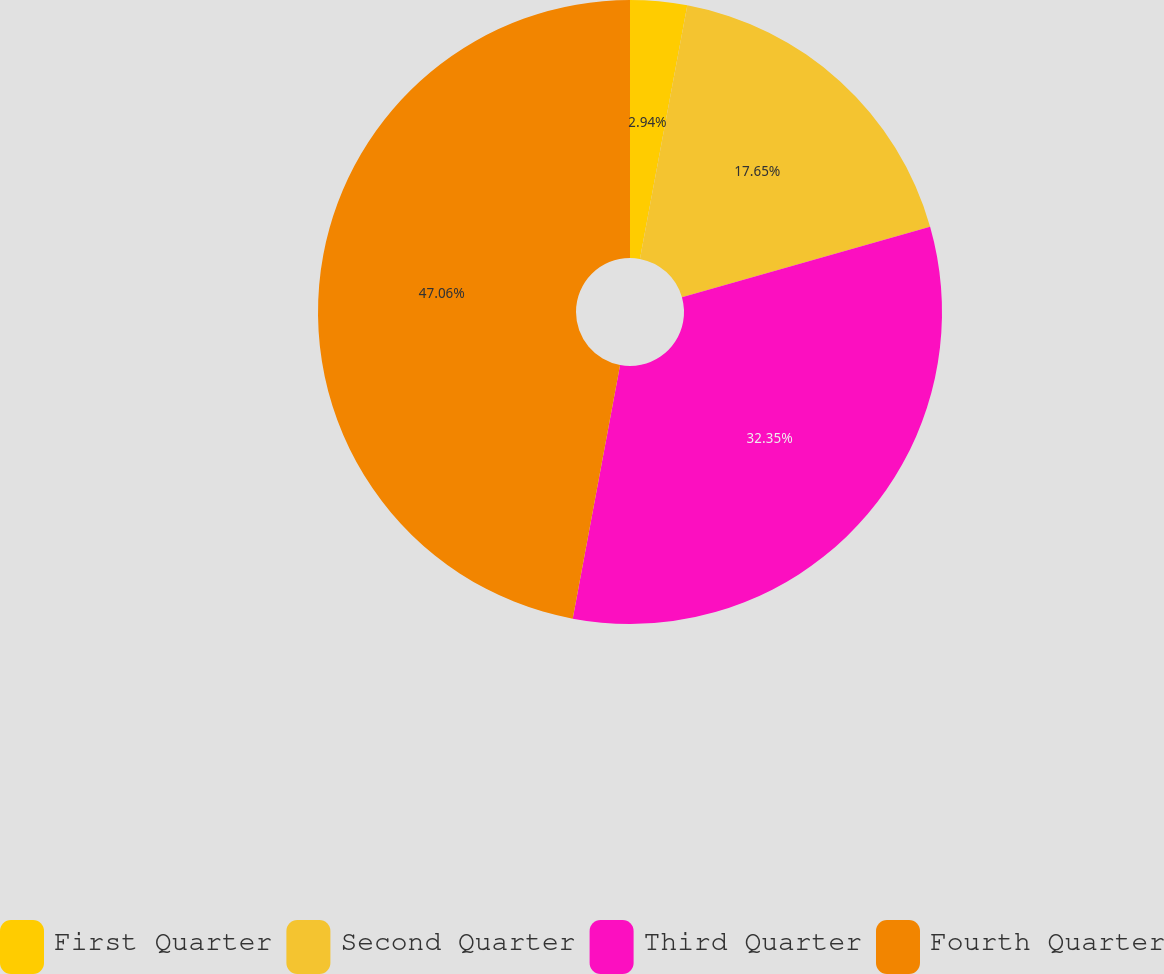Convert chart to OTSL. <chart><loc_0><loc_0><loc_500><loc_500><pie_chart><fcel>First Quarter<fcel>Second Quarter<fcel>Third Quarter<fcel>Fourth Quarter<nl><fcel>2.94%<fcel>17.65%<fcel>32.35%<fcel>47.06%<nl></chart> 